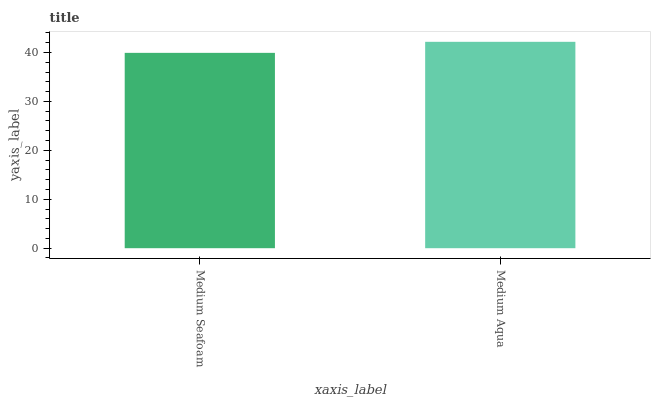Is Medium Aqua the minimum?
Answer yes or no. No. Is Medium Aqua greater than Medium Seafoam?
Answer yes or no. Yes. Is Medium Seafoam less than Medium Aqua?
Answer yes or no. Yes. Is Medium Seafoam greater than Medium Aqua?
Answer yes or no. No. Is Medium Aqua less than Medium Seafoam?
Answer yes or no. No. Is Medium Aqua the high median?
Answer yes or no. Yes. Is Medium Seafoam the low median?
Answer yes or no. Yes. Is Medium Seafoam the high median?
Answer yes or no. No. Is Medium Aqua the low median?
Answer yes or no. No. 